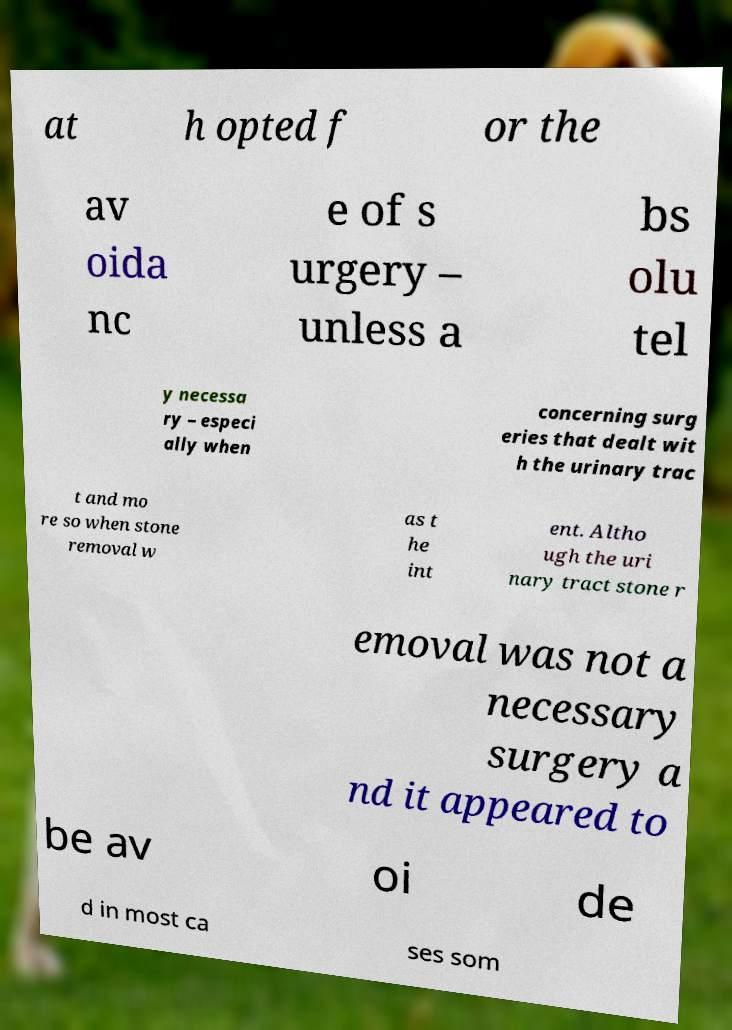What messages or text are displayed in this image? I need them in a readable, typed format. at h opted f or the av oida nc e of s urgery – unless a bs olu tel y necessa ry – especi ally when concerning surg eries that dealt wit h the urinary trac t and mo re so when stone removal w as t he int ent. Altho ugh the uri nary tract stone r emoval was not a necessary surgery a nd it appeared to be av oi de d in most ca ses som 